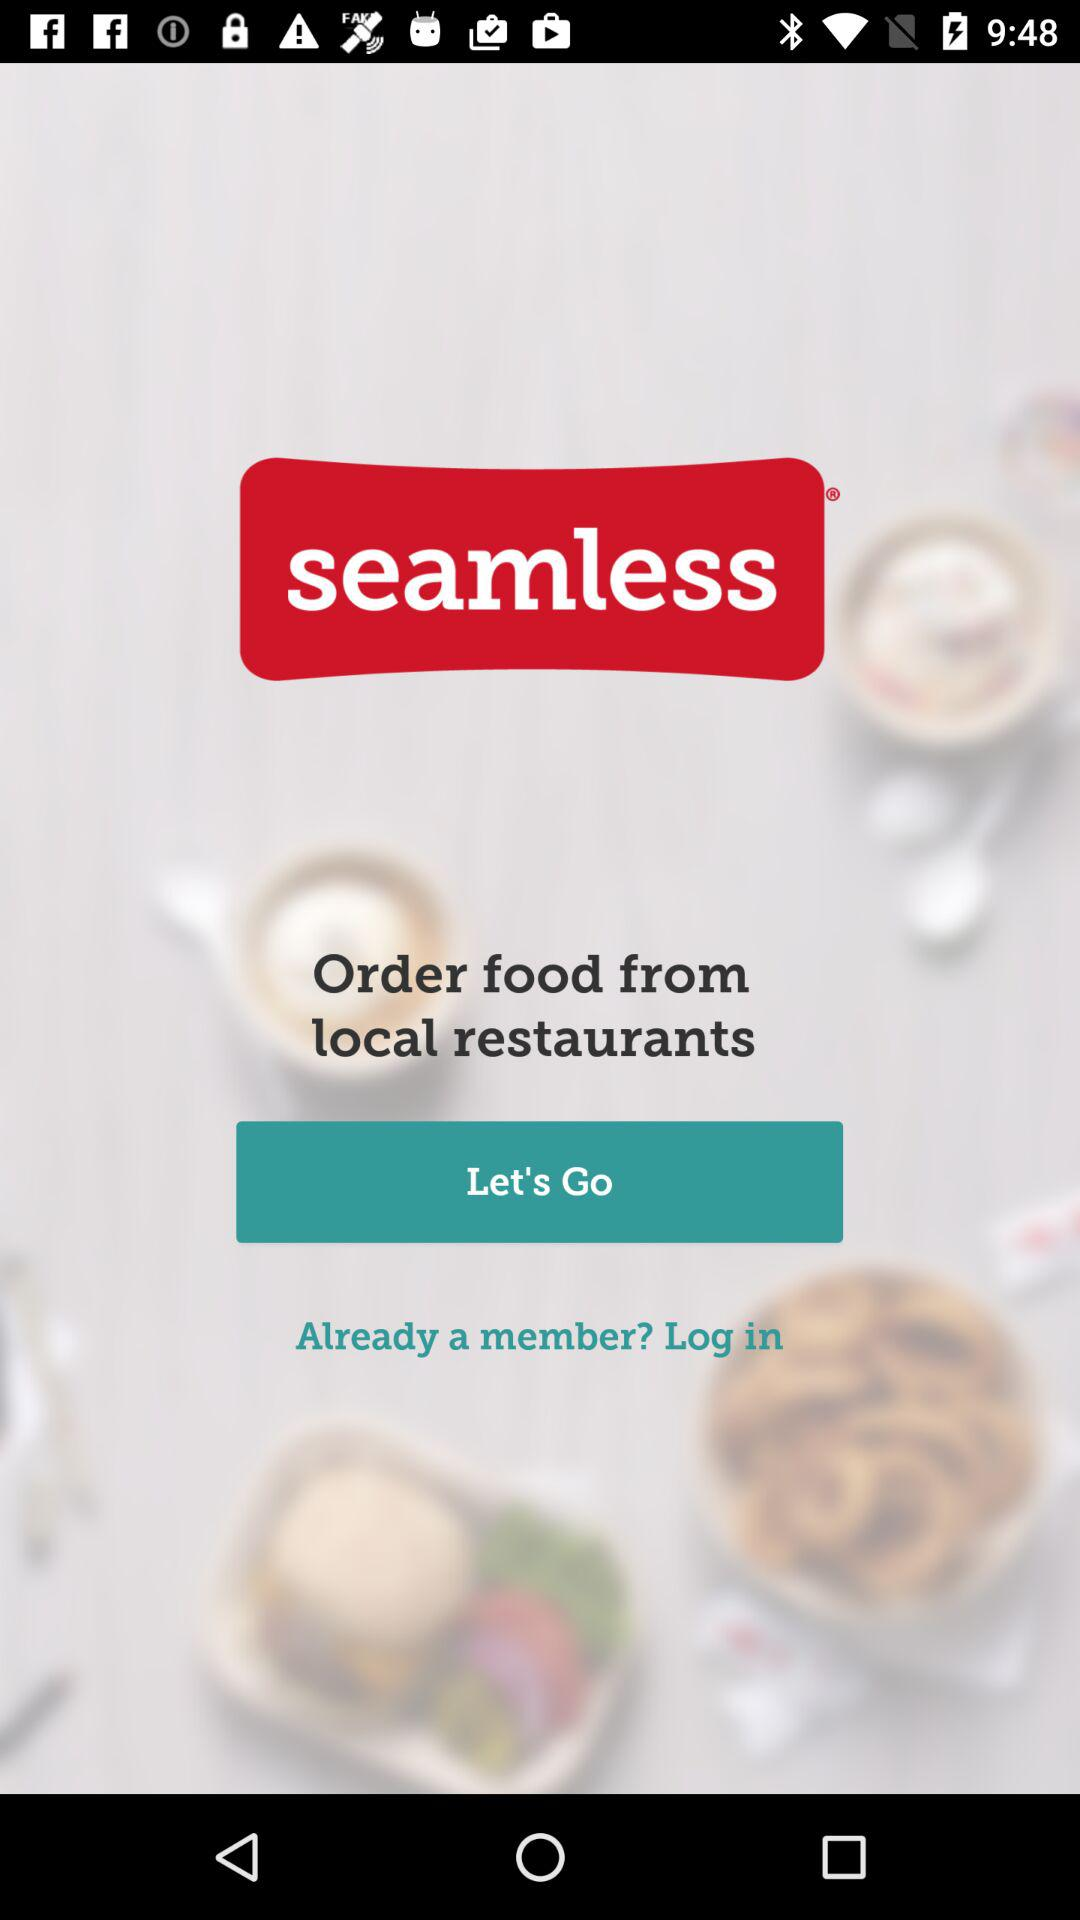What is the name of the application? The name of the application is "seamless". 